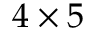<formula> <loc_0><loc_0><loc_500><loc_500>4 \times 5</formula> 